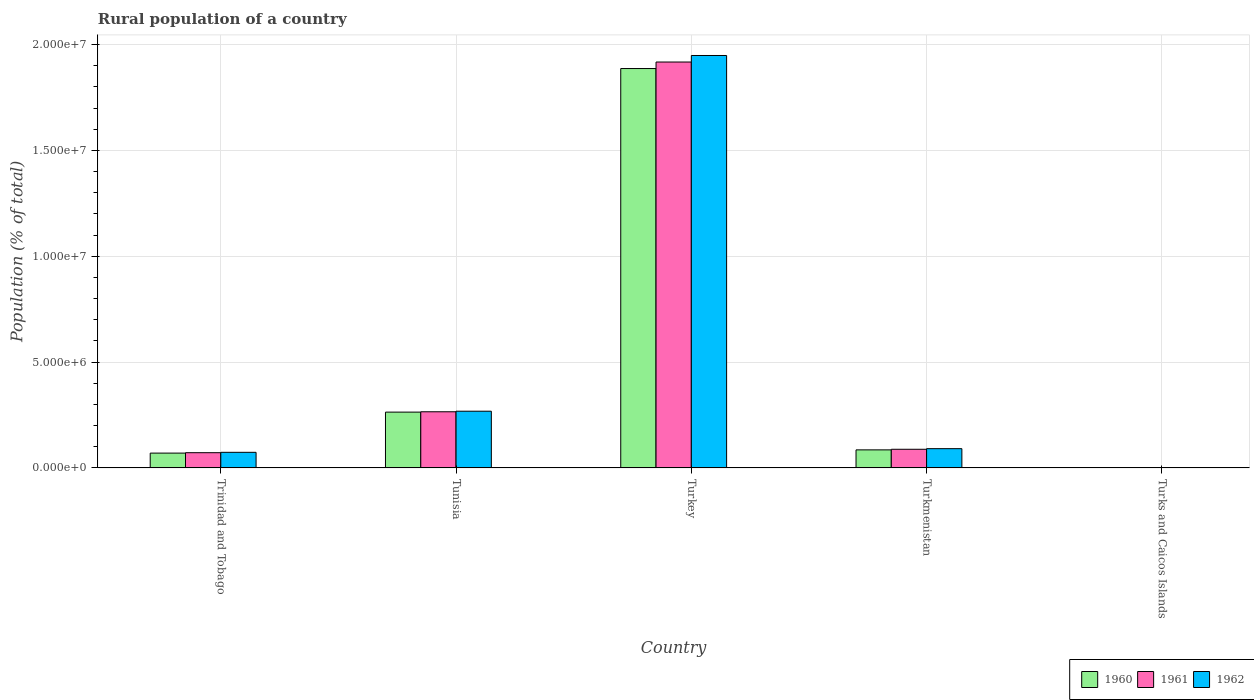How many bars are there on the 2nd tick from the left?
Keep it short and to the point. 3. What is the rural population in 1962 in Turkey?
Your answer should be very brief. 1.95e+07. Across all countries, what is the maximum rural population in 1962?
Offer a terse response. 1.95e+07. Across all countries, what is the minimum rural population in 1961?
Your answer should be compact. 2994. In which country was the rural population in 1960 minimum?
Provide a short and direct response. Turks and Caicos Islands. What is the total rural population in 1960 in the graph?
Your response must be concise. 2.31e+07. What is the difference between the rural population in 1962 in Trinidad and Tobago and that in Turkmenistan?
Your answer should be compact. -1.72e+05. What is the difference between the rural population in 1962 in Tunisia and the rural population in 1961 in Turkmenistan?
Ensure brevity in your answer.  1.80e+06. What is the average rural population in 1962 per country?
Your response must be concise. 4.76e+06. What is the difference between the rural population of/in 1962 and rural population of/in 1960 in Turkmenistan?
Give a very brief answer. 5.68e+04. What is the ratio of the rural population in 1961 in Tunisia to that in Turkmenistan?
Offer a very short reply. 3.01. What is the difference between the highest and the second highest rural population in 1962?
Provide a short and direct response. -1.68e+07. What is the difference between the highest and the lowest rural population in 1962?
Your answer should be very brief. 1.95e+07. What does the 1st bar from the left in Turkey represents?
Ensure brevity in your answer.  1960. Is it the case that in every country, the sum of the rural population in 1961 and rural population in 1960 is greater than the rural population in 1962?
Keep it short and to the point. Yes. How many bars are there?
Your response must be concise. 15. Are all the bars in the graph horizontal?
Ensure brevity in your answer.  No. Does the graph contain any zero values?
Make the answer very short. No. Does the graph contain grids?
Give a very brief answer. Yes. How many legend labels are there?
Ensure brevity in your answer.  3. How are the legend labels stacked?
Give a very brief answer. Horizontal. What is the title of the graph?
Provide a succinct answer. Rural population of a country. What is the label or title of the X-axis?
Keep it short and to the point. Country. What is the label or title of the Y-axis?
Your response must be concise. Population (% of total). What is the Population (% of total) of 1960 in Trinidad and Tobago?
Offer a very short reply. 7.01e+05. What is the Population (% of total) of 1961 in Trinidad and Tobago?
Your response must be concise. 7.21e+05. What is the Population (% of total) of 1962 in Trinidad and Tobago?
Provide a short and direct response. 7.38e+05. What is the Population (% of total) in 1960 in Tunisia?
Ensure brevity in your answer.  2.64e+06. What is the Population (% of total) of 1961 in Tunisia?
Provide a short and direct response. 2.65e+06. What is the Population (% of total) of 1962 in Tunisia?
Make the answer very short. 2.68e+06. What is the Population (% of total) of 1960 in Turkey?
Make the answer very short. 1.89e+07. What is the Population (% of total) of 1961 in Turkey?
Provide a short and direct response. 1.92e+07. What is the Population (% of total) of 1962 in Turkey?
Keep it short and to the point. 1.95e+07. What is the Population (% of total) of 1960 in Turkmenistan?
Give a very brief answer. 8.54e+05. What is the Population (% of total) of 1961 in Turkmenistan?
Provide a succinct answer. 8.82e+05. What is the Population (% of total) in 1962 in Turkmenistan?
Offer a terse response. 9.11e+05. What is the Population (% of total) in 1960 in Turks and Caicos Islands?
Provide a short and direct response. 2995. What is the Population (% of total) of 1961 in Turks and Caicos Islands?
Your answer should be very brief. 2994. What is the Population (% of total) in 1962 in Turks and Caicos Islands?
Your answer should be very brief. 2975. Across all countries, what is the maximum Population (% of total) in 1960?
Offer a very short reply. 1.89e+07. Across all countries, what is the maximum Population (% of total) of 1961?
Offer a very short reply. 1.92e+07. Across all countries, what is the maximum Population (% of total) in 1962?
Keep it short and to the point. 1.95e+07. Across all countries, what is the minimum Population (% of total) in 1960?
Provide a short and direct response. 2995. Across all countries, what is the minimum Population (% of total) in 1961?
Keep it short and to the point. 2994. Across all countries, what is the minimum Population (% of total) of 1962?
Give a very brief answer. 2975. What is the total Population (% of total) in 1960 in the graph?
Your response must be concise. 2.31e+07. What is the total Population (% of total) of 1961 in the graph?
Keep it short and to the point. 2.34e+07. What is the total Population (% of total) of 1962 in the graph?
Provide a short and direct response. 2.38e+07. What is the difference between the Population (% of total) of 1960 in Trinidad and Tobago and that in Tunisia?
Offer a terse response. -1.94e+06. What is the difference between the Population (% of total) in 1961 in Trinidad and Tobago and that in Tunisia?
Ensure brevity in your answer.  -1.93e+06. What is the difference between the Population (% of total) in 1962 in Trinidad and Tobago and that in Tunisia?
Provide a short and direct response. -1.94e+06. What is the difference between the Population (% of total) of 1960 in Trinidad and Tobago and that in Turkey?
Offer a terse response. -1.82e+07. What is the difference between the Population (% of total) of 1961 in Trinidad and Tobago and that in Turkey?
Provide a short and direct response. -1.85e+07. What is the difference between the Population (% of total) of 1962 in Trinidad and Tobago and that in Turkey?
Your response must be concise. -1.87e+07. What is the difference between the Population (% of total) in 1960 in Trinidad and Tobago and that in Turkmenistan?
Keep it short and to the point. -1.53e+05. What is the difference between the Population (% of total) of 1961 in Trinidad and Tobago and that in Turkmenistan?
Provide a short and direct response. -1.61e+05. What is the difference between the Population (% of total) in 1962 in Trinidad and Tobago and that in Turkmenistan?
Your answer should be very brief. -1.72e+05. What is the difference between the Population (% of total) of 1960 in Trinidad and Tobago and that in Turks and Caicos Islands?
Your answer should be compact. 6.98e+05. What is the difference between the Population (% of total) of 1961 in Trinidad and Tobago and that in Turks and Caicos Islands?
Your answer should be very brief. 7.18e+05. What is the difference between the Population (% of total) of 1962 in Trinidad and Tobago and that in Turks and Caicos Islands?
Your answer should be compact. 7.35e+05. What is the difference between the Population (% of total) of 1960 in Tunisia and that in Turkey?
Keep it short and to the point. -1.62e+07. What is the difference between the Population (% of total) of 1961 in Tunisia and that in Turkey?
Ensure brevity in your answer.  -1.65e+07. What is the difference between the Population (% of total) of 1962 in Tunisia and that in Turkey?
Your answer should be very brief. -1.68e+07. What is the difference between the Population (% of total) of 1960 in Tunisia and that in Turkmenistan?
Your response must be concise. 1.78e+06. What is the difference between the Population (% of total) of 1961 in Tunisia and that in Turkmenistan?
Give a very brief answer. 1.77e+06. What is the difference between the Population (% of total) of 1962 in Tunisia and that in Turkmenistan?
Your answer should be very brief. 1.77e+06. What is the difference between the Population (% of total) in 1960 in Tunisia and that in Turks and Caicos Islands?
Keep it short and to the point. 2.63e+06. What is the difference between the Population (% of total) of 1961 in Tunisia and that in Turks and Caicos Islands?
Offer a terse response. 2.65e+06. What is the difference between the Population (% of total) in 1962 in Tunisia and that in Turks and Caicos Islands?
Your response must be concise. 2.68e+06. What is the difference between the Population (% of total) in 1960 in Turkey and that in Turkmenistan?
Your answer should be very brief. 1.80e+07. What is the difference between the Population (% of total) of 1961 in Turkey and that in Turkmenistan?
Give a very brief answer. 1.83e+07. What is the difference between the Population (% of total) of 1962 in Turkey and that in Turkmenistan?
Ensure brevity in your answer.  1.86e+07. What is the difference between the Population (% of total) of 1960 in Turkey and that in Turks and Caicos Islands?
Keep it short and to the point. 1.89e+07. What is the difference between the Population (% of total) of 1961 in Turkey and that in Turks and Caicos Islands?
Provide a short and direct response. 1.92e+07. What is the difference between the Population (% of total) of 1962 in Turkey and that in Turks and Caicos Islands?
Your answer should be very brief. 1.95e+07. What is the difference between the Population (% of total) in 1960 in Turkmenistan and that in Turks and Caicos Islands?
Keep it short and to the point. 8.51e+05. What is the difference between the Population (% of total) of 1961 in Turkmenistan and that in Turks and Caicos Islands?
Your answer should be very brief. 8.79e+05. What is the difference between the Population (% of total) in 1962 in Turkmenistan and that in Turks and Caicos Islands?
Provide a short and direct response. 9.08e+05. What is the difference between the Population (% of total) of 1960 in Trinidad and Tobago and the Population (% of total) of 1961 in Tunisia?
Provide a succinct answer. -1.95e+06. What is the difference between the Population (% of total) in 1960 in Trinidad and Tobago and the Population (% of total) in 1962 in Tunisia?
Ensure brevity in your answer.  -1.98e+06. What is the difference between the Population (% of total) in 1961 in Trinidad and Tobago and the Population (% of total) in 1962 in Tunisia?
Your answer should be very brief. -1.96e+06. What is the difference between the Population (% of total) of 1960 in Trinidad and Tobago and the Population (% of total) of 1961 in Turkey?
Your answer should be compact. -1.85e+07. What is the difference between the Population (% of total) in 1960 in Trinidad and Tobago and the Population (% of total) in 1962 in Turkey?
Ensure brevity in your answer.  -1.88e+07. What is the difference between the Population (% of total) in 1961 in Trinidad and Tobago and the Population (% of total) in 1962 in Turkey?
Provide a succinct answer. -1.88e+07. What is the difference between the Population (% of total) in 1960 in Trinidad and Tobago and the Population (% of total) in 1961 in Turkmenistan?
Your answer should be very brief. -1.80e+05. What is the difference between the Population (% of total) of 1960 in Trinidad and Tobago and the Population (% of total) of 1962 in Turkmenistan?
Provide a short and direct response. -2.09e+05. What is the difference between the Population (% of total) of 1961 in Trinidad and Tobago and the Population (% of total) of 1962 in Turkmenistan?
Offer a terse response. -1.90e+05. What is the difference between the Population (% of total) in 1960 in Trinidad and Tobago and the Population (% of total) in 1961 in Turks and Caicos Islands?
Your answer should be very brief. 6.98e+05. What is the difference between the Population (% of total) in 1960 in Trinidad and Tobago and the Population (% of total) in 1962 in Turks and Caicos Islands?
Offer a terse response. 6.98e+05. What is the difference between the Population (% of total) of 1961 in Trinidad and Tobago and the Population (% of total) of 1962 in Turks and Caicos Islands?
Offer a terse response. 7.18e+05. What is the difference between the Population (% of total) in 1960 in Tunisia and the Population (% of total) in 1961 in Turkey?
Your answer should be compact. -1.65e+07. What is the difference between the Population (% of total) of 1960 in Tunisia and the Population (% of total) of 1962 in Turkey?
Your response must be concise. -1.68e+07. What is the difference between the Population (% of total) in 1961 in Tunisia and the Population (% of total) in 1962 in Turkey?
Ensure brevity in your answer.  -1.68e+07. What is the difference between the Population (% of total) in 1960 in Tunisia and the Population (% of total) in 1961 in Turkmenistan?
Your answer should be very brief. 1.76e+06. What is the difference between the Population (% of total) of 1960 in Tunisia and the Population (% of total) of 1962 in Turkmenistan?
Keep it short and to the point. 1.73e+06. What is the difference between the Population (% of total) of 1961 in Tunisia and the Population (% of total) of 1962 in Turkmenistan?
Provide a succinct answer. 1.74e+06. What is the difference between the Population (% of total) of 1960 in Tunisia and the Population (% of total) of 1961 in Turks and Caicos Islands?
Offer a very short reply. 2.63e+06. What is the difference between the Population (% of total) of 1960 in Tunisia and the Population (% of total) of 1962 in Turks and Caicos Islands?
Give a very brief answer. 2.63e+06. What is the difference between the Population (% of total) of 1961 in Tunisia and the Population (% of total) of 1962 in Turks and Caicos Islands?
Provide a succinct answer. 2.65e+06. What is the difference between the Population (% of total) of 1960 in Turkey and the Population (% of total) of 1961 in Turkmenistan?
Your response must be concise. 1.80e+07. What is the difference between the Population (% of total) in 1960 in Turkey and the Population (% of total) in 1962 in Turkmenistan?
Offer a terse response. 1.80e+07. What is the difference between the Population (% of total) of 1961 in Turkey and the Population (% of total) of 1962 in Turkmenistan?
Your answer should be very brief. 1.83e+07. What is the difference between the Population (% of total) of 1960 in Turkey and the Population (% of total) of 1961 in Turks and Caicos Islands?
Provide a succinct answer. 1.89e+07. What is the difference between the Population (% of total) of 1960 in Turkey and the Population (% of total) of 1962 in Turks and Caicos Islands?
Offer a terse response. 1.89e+07. What is the difference between the Population (% of total) of 1961 in Turkey and the Population (% of total) of 1962 in Turks and Caicos Islands?
Provide a short and direct response. 1.92e+07. What is the difference between the Population (% of total) in 1960 in Turkmenistan and the Population (% of total) in 1961 in Turks and Caicos Islands?
Provide a short and direct response. 8.51e+05. What is the difference between the Population (% of total) in 1960 in Turkmenistan and the Population (% of total) in 1962 in Turks and Caicos Islands?
Ensure brevity in your answer.  8.51e+05. What is the difference between the Population (% of total) in 1961 in Turkmenistan and the Population (% of total) in 1962 in Turks and Caicos Islands?
Provide a short and direct response. 8.79e+05. What is the average Population (% of total) in 1960 per country?
Provide a short and direct response. 4.61e+06. What is the average Population (% of total) in 1961 per country?
Provide a succinct answer. 4.69e+06. What is the average Population (% of total) of 1962 per country?
Your answer should be very brief. 4.76e+06. What is the difference between the Population (% of total) in 1960 and Population (% of total) in 1961 in Trinidad and Tobago?
Ensure brevity in your answer.  -1.95e+04. What is the difference between the Population (% of total) in 1960 and Population (% of total) in 1962 in Trinidad and Tobago?
Make the answer very short. -3.71e+04. What is the difference between the Population (% of total) of 1961 and Population (% of total) of 1962 in Trinidad and Tobago?
Your answer should be compact. -1.77e+04. What is the difference between the Population (% of total) in 1960 and Population (% of total) in 1961 in Tunisia?
Ensure brevity in your answer.  -1.66e+04. What is the difference between the Population (% of total) in 1960 and Population (% of total) in 1962 in Tunisia?
Keep it short and to the point. -4.30e+04. What is the difference between the Population (% of total) of 1961 and Population (% of total) of 1962 in Tunisia?
Offer a terse response. -2.64e+04. What is the difference between the Population (% of total) of 1960 and Population (% of total) of 1961 in Turkey?
Make the answer very short. -3.08e+05. What is the difference between the Population (% of total) of 1960 and Population (% of total) of 1962 in Turkey?
Keep it short and to the point. -6.16e+05. What is the difference between the Population (% of total) in 1961 and Population (% of total) in 1962 in Turkey?
Offer a terse response. -3.08e+05. What is the difference between the Population (% of total) in 1960 and Population (% of total) in 1961 in Turkmenistan?
Your response must be concise. -2.78e+04. What is the difference between the Population (% of total) of 1960 and Population (% of total) of 1962 in Turkmenistan?
Your response must be concise. -5.68e+04. What is the difference between the Population (% of total) in 1961 and Population (% of total) in 1962 in Turkmenistan?
Give a very brief answer. -2.89e+04. What is the difference between the Population (% of total) of 1960 and Population (% of total) of 1961 in Turks and Caicos Islands?
Give a very brief answer. 1. What is the ratio of the Population (% of total) of 1960 in Trinidad and Tobago to that in Tunisia?
Provide a short and direct response. 0.27. What is the ratio of the Population (% of total) of 1961 in Trinidad and Tobago to that in Tunisia?
Offer a very short reply. 0.27. What is the ratio of the Population (% of total) in 1962 in Trinidad and Tobago to that in Tunisia?
Your answer should be very brief. 0.28. What is the ratio of the Population (% of total) in 1960 in Trinidad and Tobago to that in Turkey?
Your response must be concise. 0.04. What is the ratio of the Population (% of total) in 1961 in Trinidad and Tobago to that in Turkey?
Provide a short and direct response. 0.04. What is the ratio of the Population (% of total) of 1962 in Trinidad and Tobago to that in Turkey?
Make the answer very short. 0.04. What is the ratio of the Population (% of total) of 1960 in Trinidad and Tobago to that in Turkmenistan?
Ensure brevity in your answer.  0.82. What is the ratio of the Population (% of total) of 1961 in Trinidad and Tobago to that in Turkmenistan?
Offer a terse response. 0.82. What is the ratio of the Population (% of total) in 1962 in Trinidad and Tobago to that in Turkmenistan?
Your response must be concise. 0.81. What is the ratio of the Population (% of total) of 1960 in Trinidad and Tobago to that in Turks and Caicos Islands?
Offer a very short reply. 234.15. What is the ratio of the Population (% of total) in 1961 in Trinidad and Tobago to that in Turks and Caicos Islands?
Offer a terse response. 240.73. What is the ratio of the Population (% of total) of 1962 in Trinidad and Tobago to that in Turks and Caicos Islands?
Keep it short and to the point. 248.2. What is the ratio of the Population (% of total) of 1960 in Tunisia to that in Turkey?
Offer a very short reply. 0.14. What is the ratio of the Population (% of total) in 1961 in Tunisia to that in Turkey?
Your answer should be compact. 0.14. What is the ratio of the Population (% of total) of 1962 in Tunisia to that in Turkey?
Your answer should be very brief. 0.14. What is the ratio of the Population (% of total) of 1960 in Tunisia to that in Turkmenistan?
Make the answer very short. 3.09. What is the ratio of the Population (% of total) in 1961 in Tunisia to that in Turkmenistan?
Make the answer very short. 3.01. What is the ratio of the Population (% of total) in 1962 in Tunisia to that in Turkmenistan?
Offer a very short reply. 2.94. What is the ratio of the Population (% of total) in 1960 in Tunisia to that in Turks and Caicos Islands?
Ensure brevity in your answer.  880.63. What is the ratio of the Population (% of total) in 1961 in Tunisia to that in Turks and Caicos Islands?
Provide a succinct answer. 886.48. What is the ratio of the Population (% of total) of 1962 in Tunisia to that in Turks and Caicos Islands?
Your answer should be very brief. 901.01. What is the ratio of the Population (% of total) in 1960 in Turkey to that in Turkmenistan?
Your answer should be very brief. 22.1. What is the ratio of the Population (% of total) in 1961 in Turkey to that in Turkmenistan?
Keep it short and to the point. 21.75. What is the ratio of the Population (% of total) of 1962 in Turkey to that in Turkmenistan?
Make the answer very short. 21.4. What is the ratio of the Population (% of total) of 1960 in Turkey to that in Turks and Caicos Islands?
Make the answer very short. 6300.46. What is the ratio of the Population (% of total) in 1961 in Turkey to that in Turks and Caicos Islands?
Provide a short and direct response. 6405.43. What is the ratio of the Population (% of total) in 1962 in Turkey to that in Turks and Caicos Islands?
Give a very brief answer. 6549.89. What is the ratio of the Population (% of total) of 1960 in Turkmenistan to that in Turks and Caicos Islands?
Provide a short and direct response. 285.12. What is the ratio of the Population (% of total) of 1961 in Turkmenistan to that in Turks and Caicos Islands?
Provide a short and direct response. 294.51. What is the ratio of the Population (% of total) of 1962 in Turkmenistan to that in Turks and Caicos Islands?
Your response must be concise. 306.12. What is the difference between the highest and the second highest Population (% of total) in 1960?
Make the answer very short. 1.62e+07. What is the difference between the highest and the second highest Population (% of total) of 1961?
Give a very brief answer. 1.65e+07. What is the difference between the highest and the second highest Population (% of total) of 1962?
Offer a terse response. 1.68e+07. What is the difference between the highest and the lowest Population (% of total) of 1960?
Your answer should be compact. 1.89e+07. What is the difference between the highest and the lowest Population (% of total) of 1961?
Ensure brevity in your answer.  1.92e+07. What is the difference between the highest and the lowest Population (% of total) of 1962?
Your answer should be compact. 1.95e+07. 